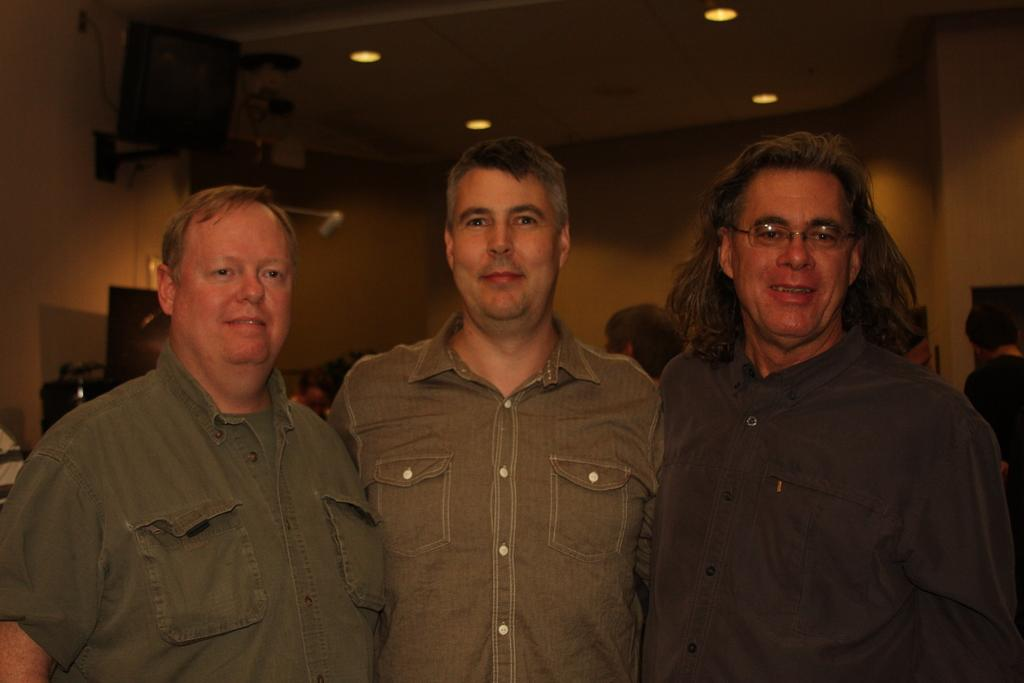How many people are present in the image? There are three persons standing in the image. What is the facial expression of the people in the image? The three persons are smiling. What can be seen in the background of the image? There is a group of people, lights, and a wall visible in the background of the image. What type of order can be seen being processed in the image? There is no order being processed in the image; it features three people standing and smiling. What type of library or office can be seen in the image? There is no library or office present in the image; it is an outdoor scene with people standing and smiling. 